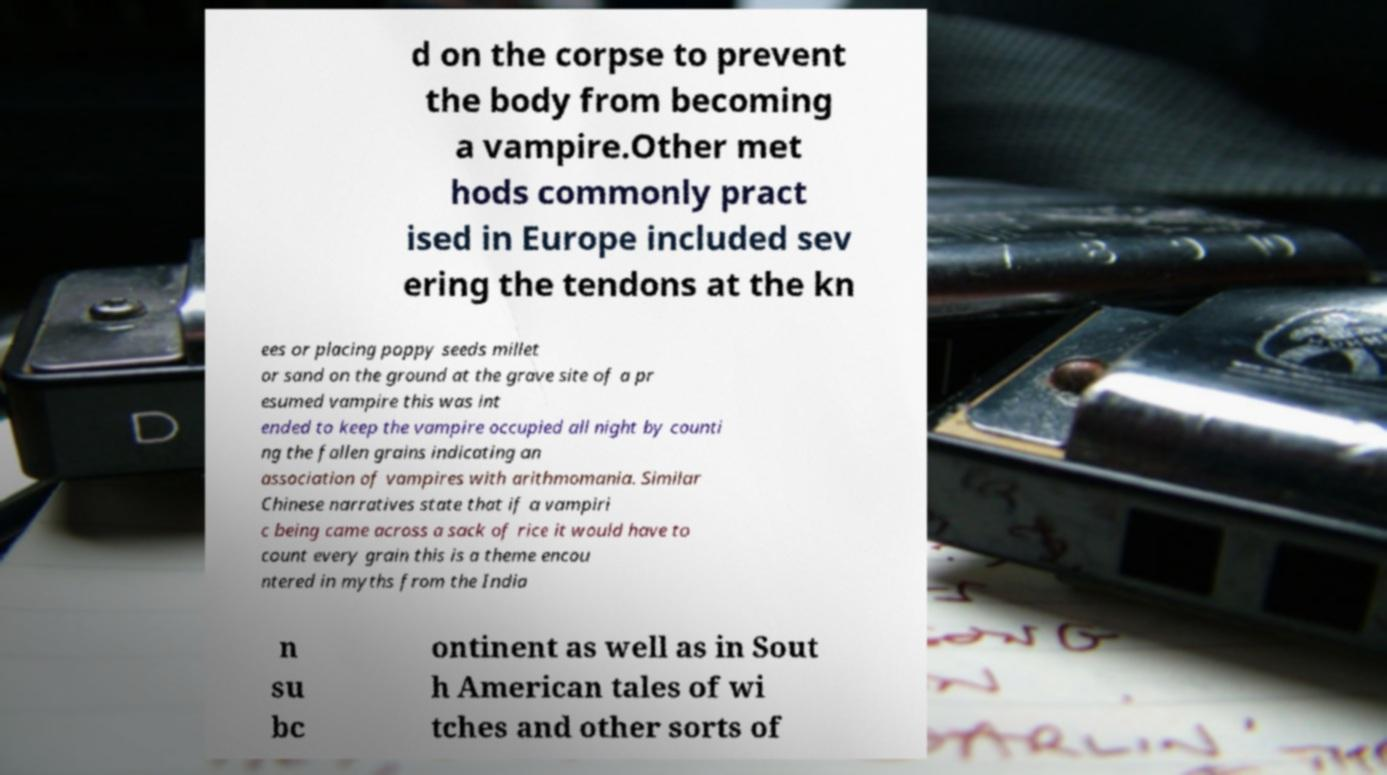There's text embedded in this image that I need extracted. Can you transcribe it verbatim? d on the corpse to prevent the body from becoming a vampire.Other met hods commonly pract ised in Europe included sev ering the tendons at the kn ees or placing poppy seeds millet or sand on the ground at the grave site of a pr esumed vampire this was int ended to keep the vampire occupied all night by counti ng the fallen grains indicating an association of vampires with arithmomania. Similar Chinese narratives state that if a vampiri c being came across a sack of rice it would have to count every grain this is a theme encou ntered in myths from the India n su bc ontinent as well as in Sout h American tales of wi tches and other sorts of 